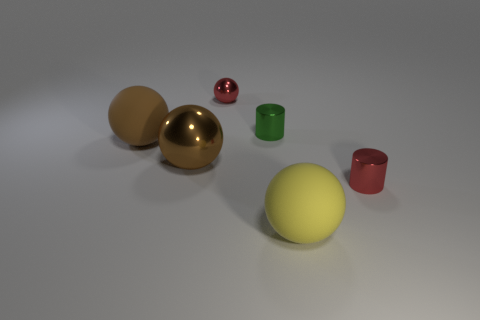There is a shiny thing that is the same color as the tiny sphere; what size is it?
Give a very brief answer. Small. What shape is the other large object that is the same color as the big shiny object?
Your answer should be compact. Sphere. Do the matte ball to the right of the red sphere and the matte ball behind the yellow ball have the same size?
Give a very brief answer. Yes. Are there an equal number of big metal objects that are to the right of the green metallic object and brown metallic balls that are on the right side of the tiny red shiny cylinder?
Your response must be concise. Yes. Does the green cylinder have the same size as the matte thing that is to the left of the small green metal thing?
Offer a terse response. No. There is a shiny cylinder that is on the left side of the large yellow thing; are there any red shiny things on the right side of it?
Offer a very short reply. Yes. Are there any other metal things of the same shape as the big yellow thing?
Your response must be concise. Yes. How many green metal cylinders are on the left side of the tiny shiny cylinder behind the big rubber sphere that is to the left of the big metallic sphere?
Ensure brevity in your answer.  0. There is a small shiny sphere; is it the same color as the small cylinder that is behind the large brown matte object?
Your response must be concise. No. What number of objects are red things behind the green object or green metallic things left of the yellow rubber sphere?
Provide a short and direct response. 2. 